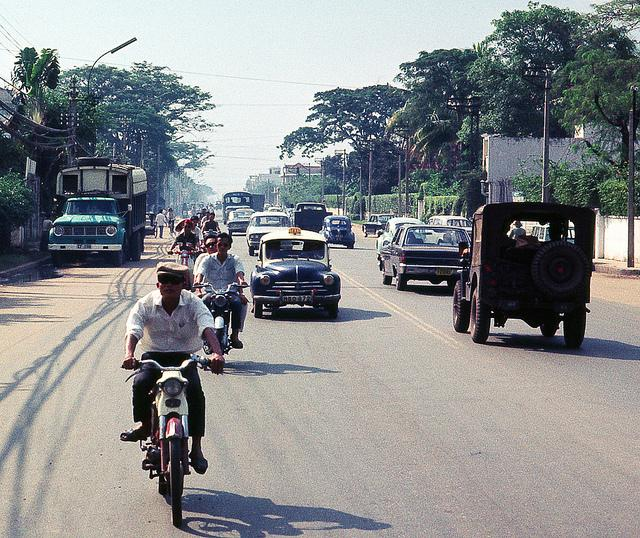What are is the image from? Please explain your reasoning. city. The structure of the road and the buildings in the background and the volume of cars visible is all consistent with answer a. 